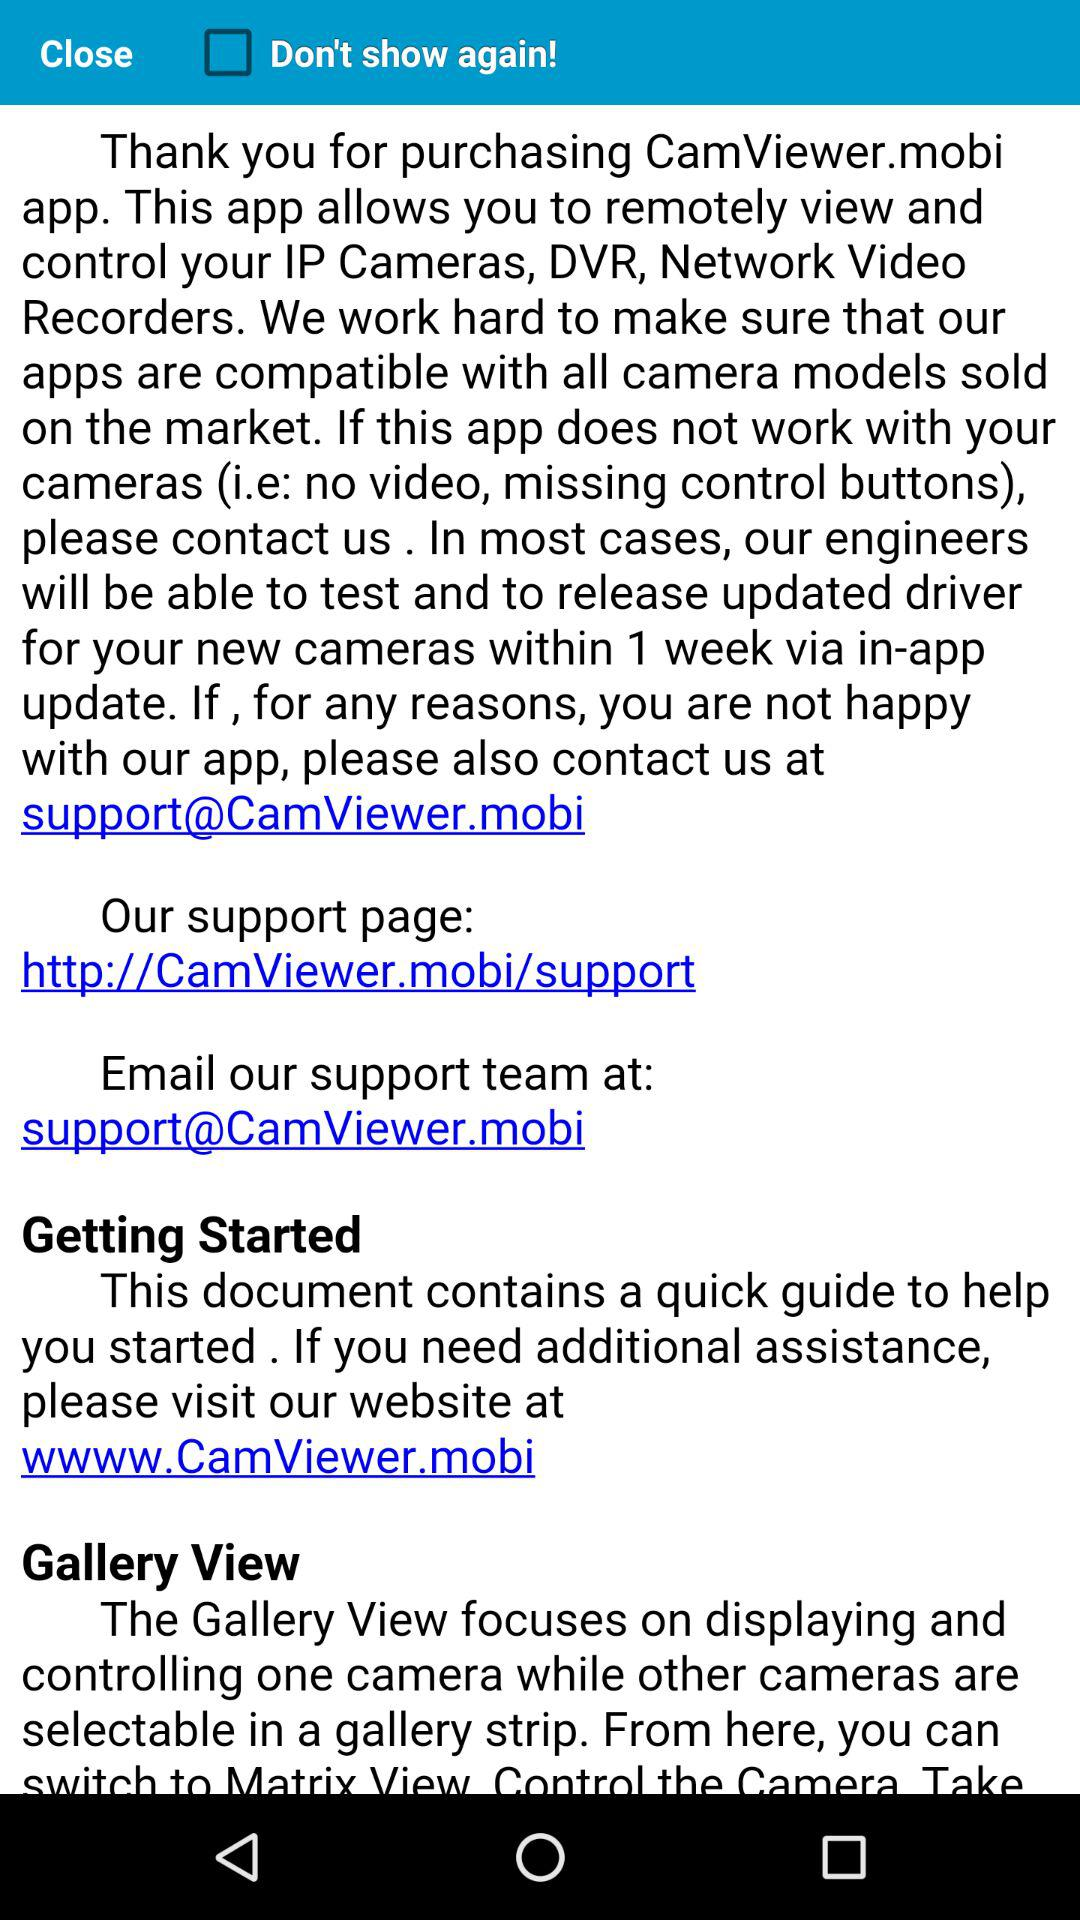What is the URL? The URL is http://CamViewer.mobi/support. 